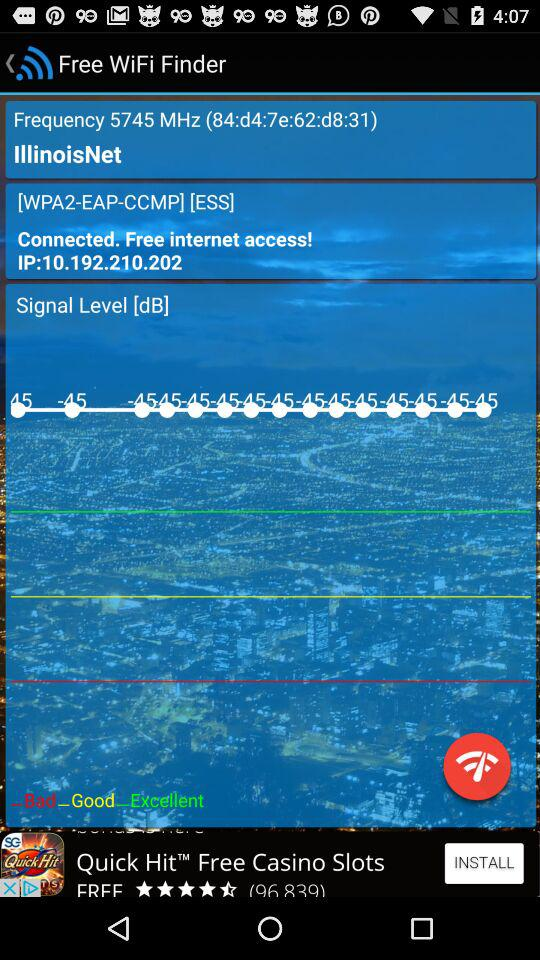What is the status of "WiFi"? The status of "WiFi" is connected. 